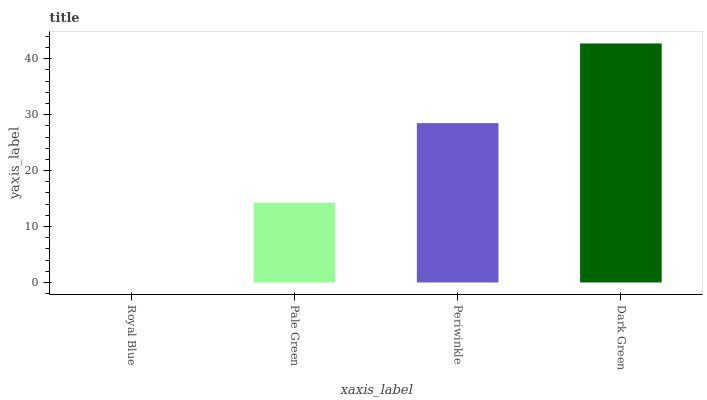Is Royal Blue the minimum?
Answer yes or no. Yes. Is Dark Green the maximum?
Answer yes or no. Yes. Is Pale Green the minimum?
Answer yes or no. No. Is Pale Green the maximum?
Answer yes or no. No. Is Pale Green greater than Royal Blue?
Answer yes or no. Yes. Is Royal Blue less than Pale Green?
Answer yes or no. Yes. Is Royal Blue greater than Pale Green?
Answer yes or no. No. Is Pale Green less than Royal Blue?
Answer yes or no. No. Is Periwinkle the high median?
Answer yes or no. Yes. Is Pale Green the low median?
Answer yes or no. Yes. Is Pale Green the high median?
Answer yes or no. No. Is Periwinkle the low median?
Answer yes or no. No. 